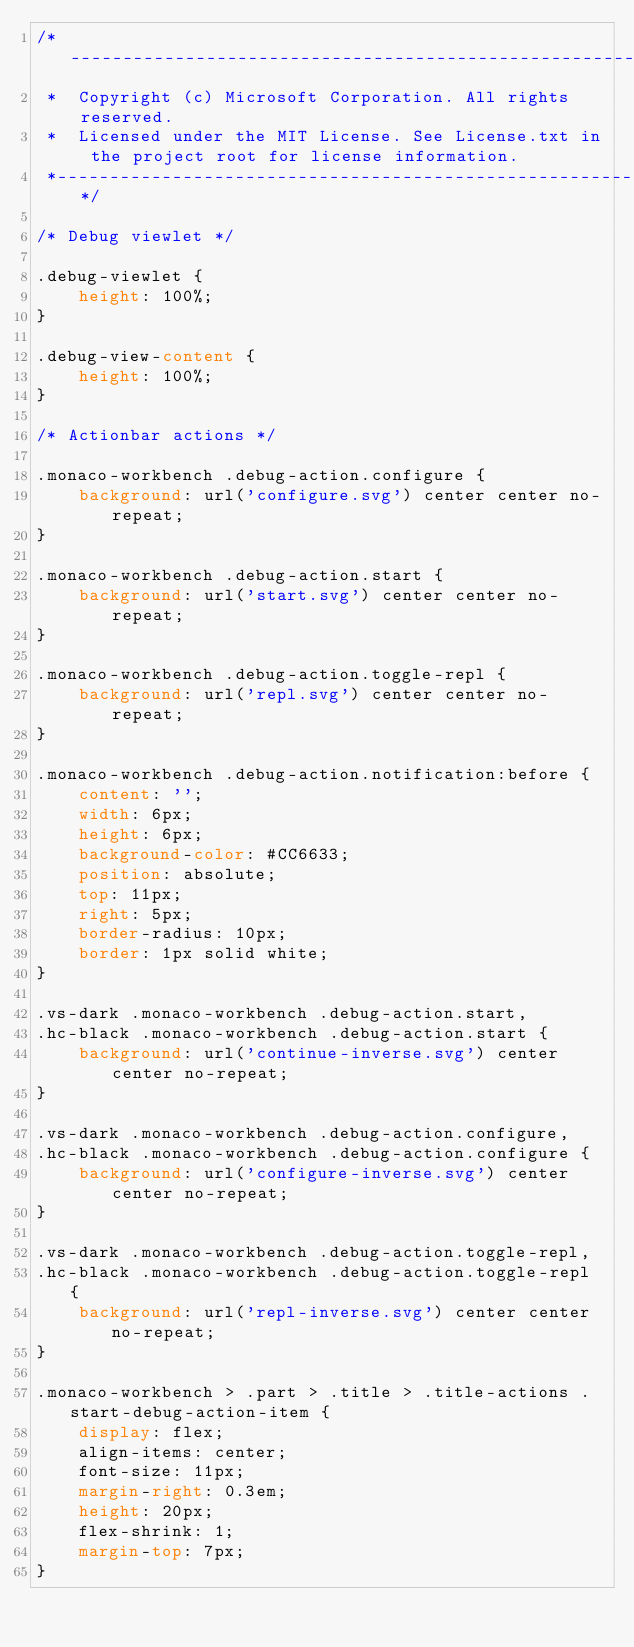<code> <loc_0><loc_0><loc_500><loc_500><_CSS_>/*---------------------------------------------------------------------------------------------
 *  Copyright (c) Microsoft Corporation. All rights reserved.
 *  Licensed under the MIT License. See License.txt in the project root for license information.
 *--------------------------------------------------------------------------------------------*/

/* Debug viewlet */

.debug-viewlet {
	height: 100%;
}

.debug-view-content {
	height: 100%;
}

/* Actionbar actions */

.monaco-workbench .debug-action.configure {
	background: url('configure.svg') center center no-repeat;
}

.monaco-workbench .debug-action.start {
	background: url('start.svg') center center no-repeat;
}

.monaco-workbench .debug-action.toggle-repl {
	background: url('repl.svg') center center no-repeat;
}

.monaco-workbench .debug-action.notification:before {
	content: '';
	width: 6px;
	height: 6px;
	background-color: #CC6633;
	position: absolute;
	top: 11px;
	right: 5px;
	border-radius: 10px;
	border: 1px solid white;
}

.vs-dark .monaco-workbench .debug-action.start,
.hc-black .monaco-workbench .debug-action.start {
	background: url('continue-inverse.svg') center center no-repeat;
}

.vs-dark .monaco-workbench .debug-action.configure,
.hc-black .monaco-workbench .debug-action.configure {
	background: url('configure-inverse.svg') center center no-repeat;
}

.vs-dark .monaco-workbench .debug-action.toggle-repl,
.hc-black .monaco-workbench .debug-action.toggle-repl {
	background: url('repl-inverse.svg') center center no-repeat;
}

.monaco-workbench > .part > .title > .title-actions .start-debug-action-item {
	display: flex;
	align-items: center;
	font-size: 11px;
	margin-right: 0.3em;
	height: 20px;
	flex-shrink: 1;
	margin-top: 7px;
}
</code> 